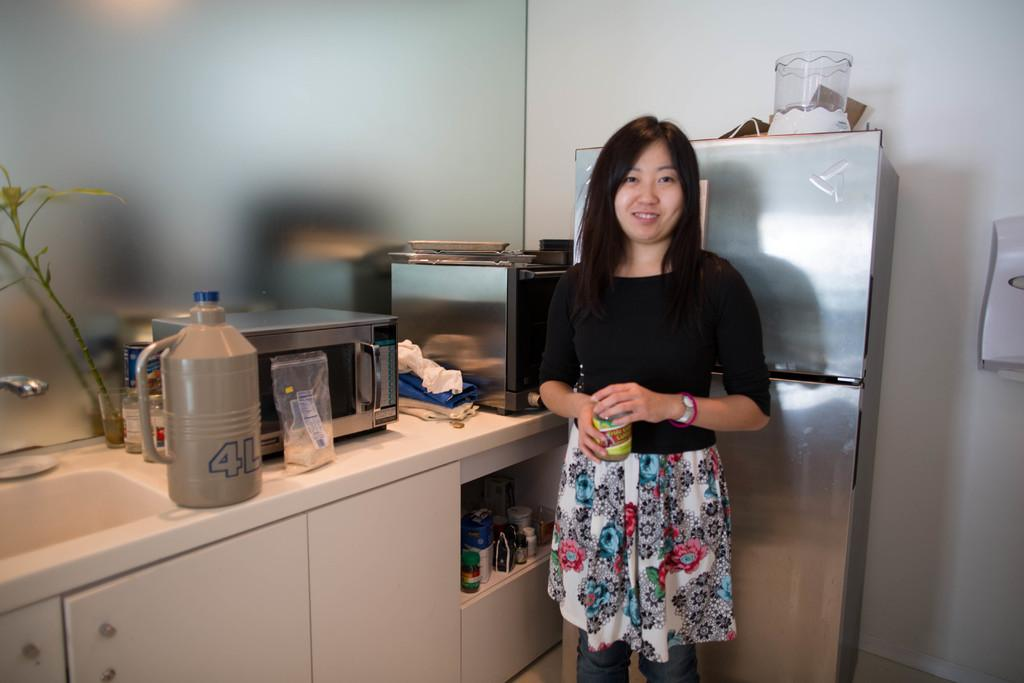Provide a one-sentence caption for the provided image. Gray and blue 4L can on a counter. 